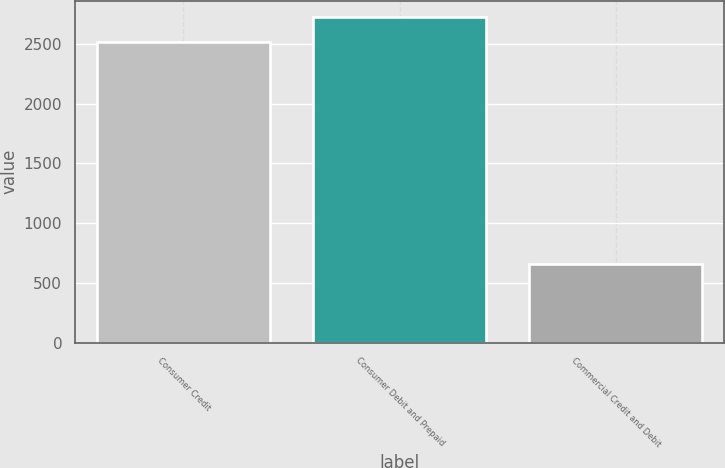Convert chart. <chart><loc_0><loc_0><loc_500><loc_500><bar_chart><fcel>Consumer Credit<fcel>Consumer Debit and Prepaid<fcel>Commercial Credit and Debit<nl><fcel>2520<fcel>2726.7<fcel>657<nl></chart> 